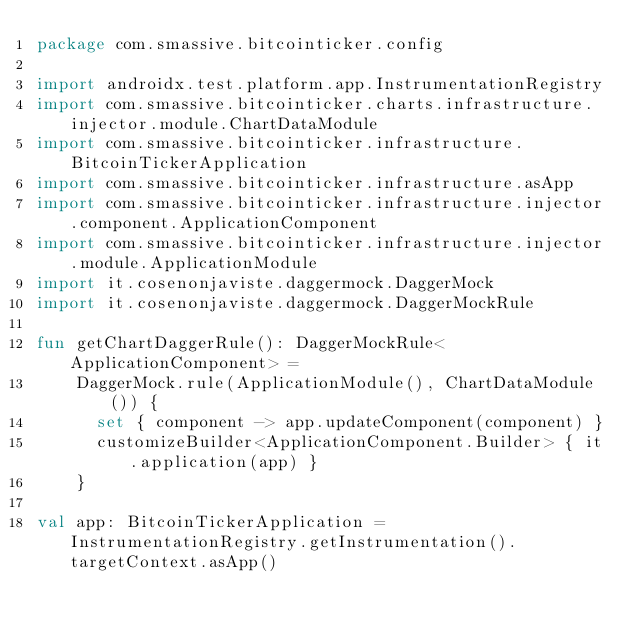Convert code to text. <code><loc_0><loc_0><loc_500><loc_500><_Kotlin_>package com.smassive.bitcointicker.config

import androidx.test.platform.app.InstrumentationRegistry
import com.smassive.bitcointicker.charts.infrastructure.injector.module.ChartDataModule
import com.smassive.bitcointicker.infrastructure.BitcoinTickerApplication
import com.smassive.bitcointicker.infrastructure.asApp
import com.smassive.bitcointicker.infrastructure.injector.component.ApplicationComponent
import com.smassive.bitcointicker.infrastructure.injector.module.ApplicationModule
import it.cosenonjaviste.daggermock.DaggerMock
import it.cosenonjaviste.daggermock.DaggerMockRule

fun getChartDaggerRule(): DaggerMockRule<ApplicationComponent> =
    DaggerMock.rule(ApplicationModule(), ChartDataModule()) {
      set { component -> app.updateComponent(component) }
      customizeBuilder<ApplicationComponent.Builder> { it.application(app) }
    }

val app: BitcoinTickerApplication = InstrumentationRegistry.getInstrumentation().targetContext.asApp()
</code> 